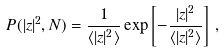Convert formula to latex. <formula><loc_0><loc_0><loc_500><loc_500>P ( | z | ^ { 2 } , N ) = \frac { 1 } { \langle | z | ^ { 2 } \rangle } \exp \left [ - \frac { | z | ^ { 2 } } { \langle | z | ^ { 2 } \rangle } \right ] \, ,</formula> 